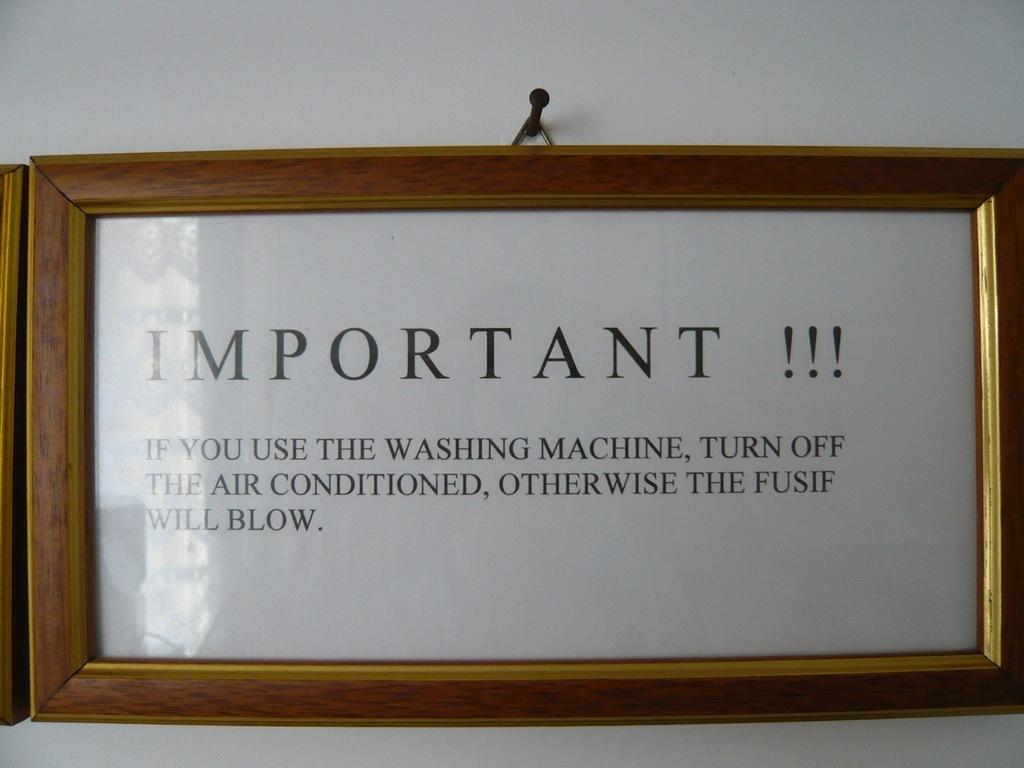Provide a one-sentence caption for the provided image. A wooden framed sign hangs on the wall making sure people turn off the washing machine when they are done with it. 